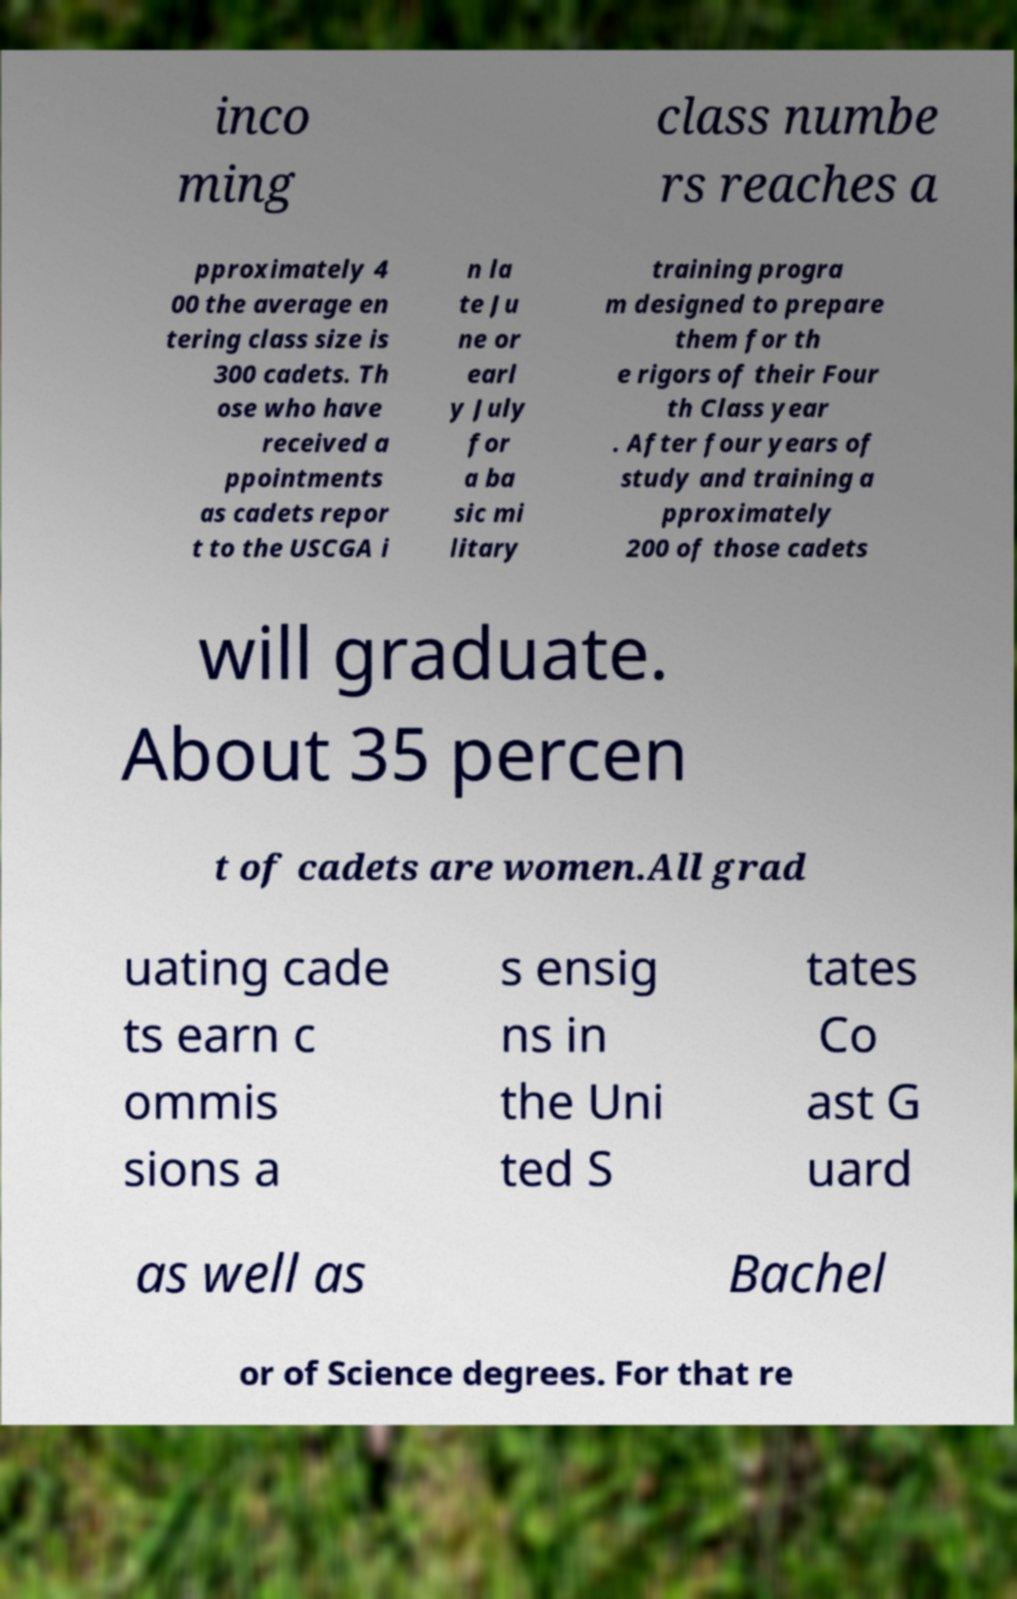Could you extract and type out the text from this image? inco ming class numbe rs reaches a pproximately 4 00 the average en tering class size is 300 cadets. Th ose who have received a ppointments as cadets repor t to the USCGA i n la te Ju ne or earl y July for a ba sic mi litary training progra m designed to prepare them for th e rigors of their Four th Class year . After four years of study and training a pproximately 200 of those cadets will graduate. About 35 percen t of cadets are women.All grad uating cade ts earn c ommis sions a s ensig ns in the Uni ted S tates Co ast G uard as well as Bachel or of Science degrees. For that re 